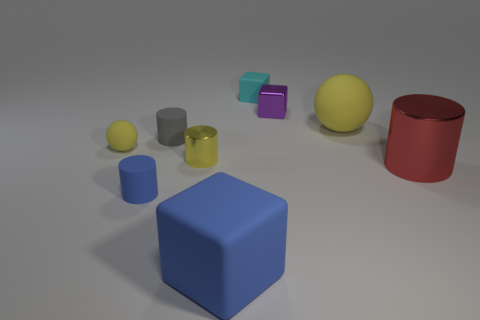There is a large sphere that is the same color as the small matte ball; what is it made of?
Provide a short and direct response. Rubber. How many big cylinders are the same color as the big block?
Offer a terse response. 0. How many things are objects that are to the right of the small blue object or balls that are to the right of the cyan block?
Offer a very short reply. 7. How many yellow objects are right of the tiny yellow thing on the left side of the tiny yellow cylinder?
Keep it short and to the point. 2. There is another tiny cylinder that is made of the same material as the small gray cylinder; what is its color?
Keep it short and to the point. Blue. Are there any brown metallic spheres that have the same size as the yellow cylinder?
Your response must be concise. No. What is the shape of the cyan matte thing that is the same size as the yellow metal cylinder?
Give a very brief answer. Cube. Are there any tiny purple objects of the same shape as the tiny gray rubber object?
Your response must be concise. No. Is the tiny purple block made of the same material as the yellow ball right of the tiny rubber ball?
Give a very brief answer. No. Are there any tiny spheres that have the same color as the small shiny cube?
Provide a succinct answer. No. 